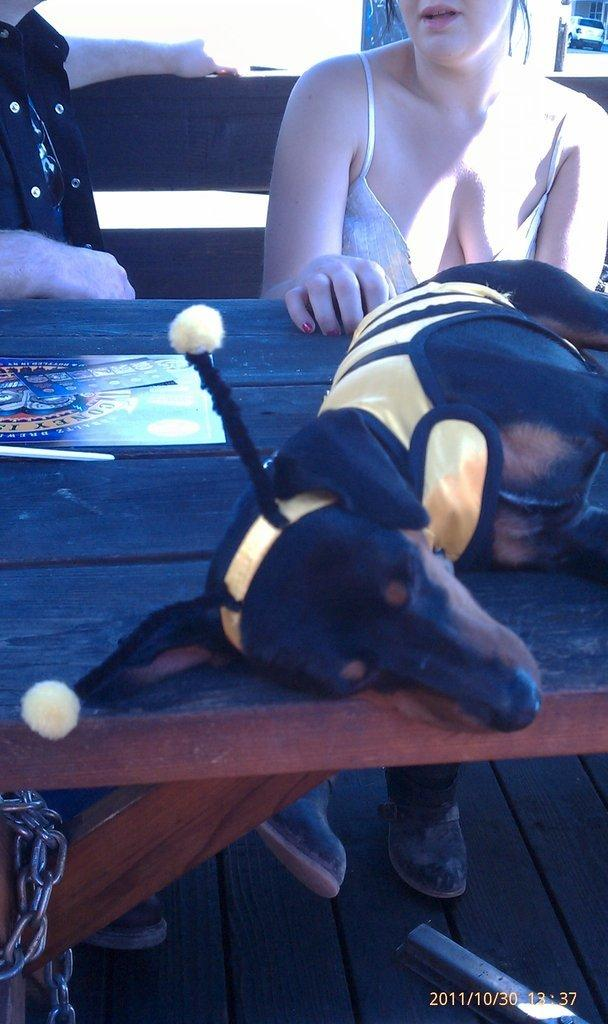What type of animal is in the image? There is a dog in the image. What colors can be seen on the dog? The dog is black and brown in color. Where is the dog located in the image? The dog is sleeping on a table. Can you describe the person visible in the background of the image? Unfortunately, the provided facts do not give any information about the person in the background. What type of rail is the dog holding in the image? There is no rail present in the image; the dog is sleeping on a table. What substance is the dog using to communicate with the person in the image? There is no substance present in the image; the dog is sleeping on a table. 